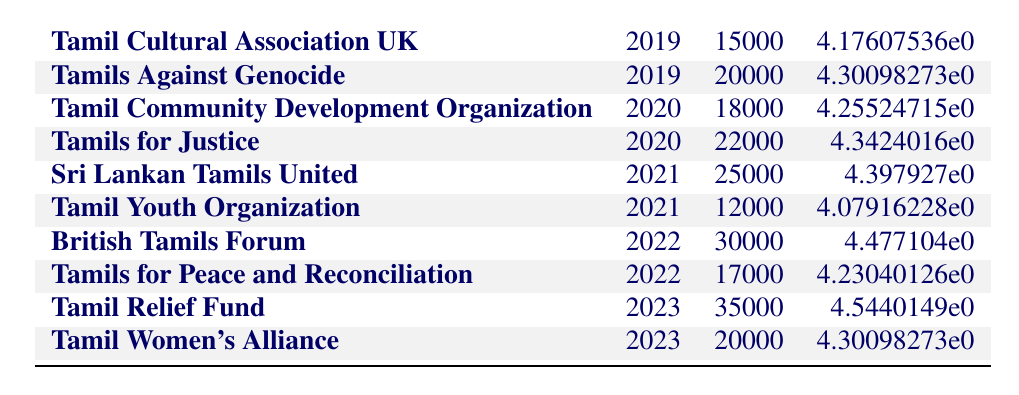What was the fundraising contribution of Tamil Cultural Association UK in 2019? The table shows the amount for Tamil Cultural Association UK in the year 2019 is £15,000.
Answer: £15,000 Which organization received the highest funding in 2022? According to the table, the British Tamils Forum received £30,000, which is higher than the £17,000 received by Tamils for Peace and Reconciliation.
Answer: British Tamils Forum What is the total amount raised by the Tamil Youth Organization in 2021? The Tamil Youth Organization raised £12,000 in 2021, which is the only entry for this organization in that year.
Answer: £12,000 Is the amount contributed to the Tamil Relief Fund in 2023 greater than the amount contributed to the Tamils for Justice in 2020? The Tamil Relief Fund received £35,000 in 2023 while Tamils for Justice received £22,000 in 2020. Since £35,000 is greater than £22,000, the answer is yes.
Answer: Yes What is the average amount raised by all organizations in 2019? The amounts raised in 2019 were £15,000 (Tamil Cultural Association UK) and £20,000 (Tamils Against Genocide). Adding these amounts (15,000 + 20,000 = 35,000) and dividing by 2 gives an average of £17,500.
Answer: £17,500 Which year saw an increase or decrease in contributions compared to the previous year? Comparing years, 2020 added £39,000 in total to £39,000 from 2019 (an increase) whereas 2021 dropped to £37,000 (a decrease). 2022 saw a significant rise to £47,000 (an increase). 2023 had contributions of £55,000 (also an increase).
Answer: Increase in 2020 and 2022; decrease in 2021 What was the total amount contributed across all organizations from 2019 to 2023? By adding all contributions from each year (15,000 + 20,000 + 18,000 + 22,000 + 25,000 + 12,000 + 30,000 + 17,000 + 35,000 + 20,000), the total comes to £249,000.
Answer: £249,000 Did the Tamil Women's Alliance raise more money than the Tamil Cultural Association UK in their respective years? The Tamil Women's Alliance raised £20,000 in 2023, while the Tamil Cultural Association UK raised £15,000 in 2019. Therefore, yes, the Tamil Women's Alliance raised more money.
Answer: Yes Compare the total contributions of the Tamils Against Genocide and Sri Lankan Tamils United. Which organization raised more? The Tamils Against Genocide raised £20,000 in 2019 and did not raise any in 2020, whereas Sri Lankan Tamils United, raised £25,000 in 2021. Adding contributions for Tamils Against Genocide gives £20,000 (total) compared to Sri Lankan Tamils United's £25,000, revealing that Sri Lankan Tamils United raised more.
Answer: Sri Lankan Tamils United 